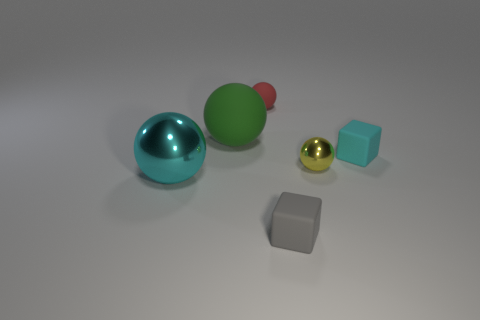Add 3 tiny gray blocks. How many objects exist? 9 Subtract all spheres. How many objects are left? 2 Subtract all tiny things. Subtract all large blue blocks. How many objects are left? 2 Add 1 small cyan cubes. How many small cyan cubes are left? 2 Add 2 red objects. How many red objects exist? 3 Subtract 1 cyan blocks. How many objects are left? 5 